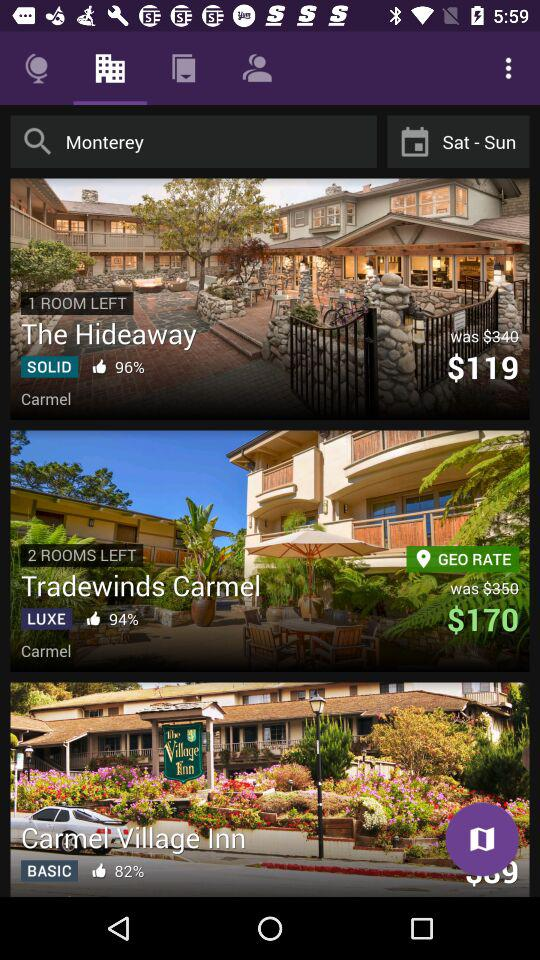How many rooms are left in "The Hideaway"? The number of rooms left is 1. 